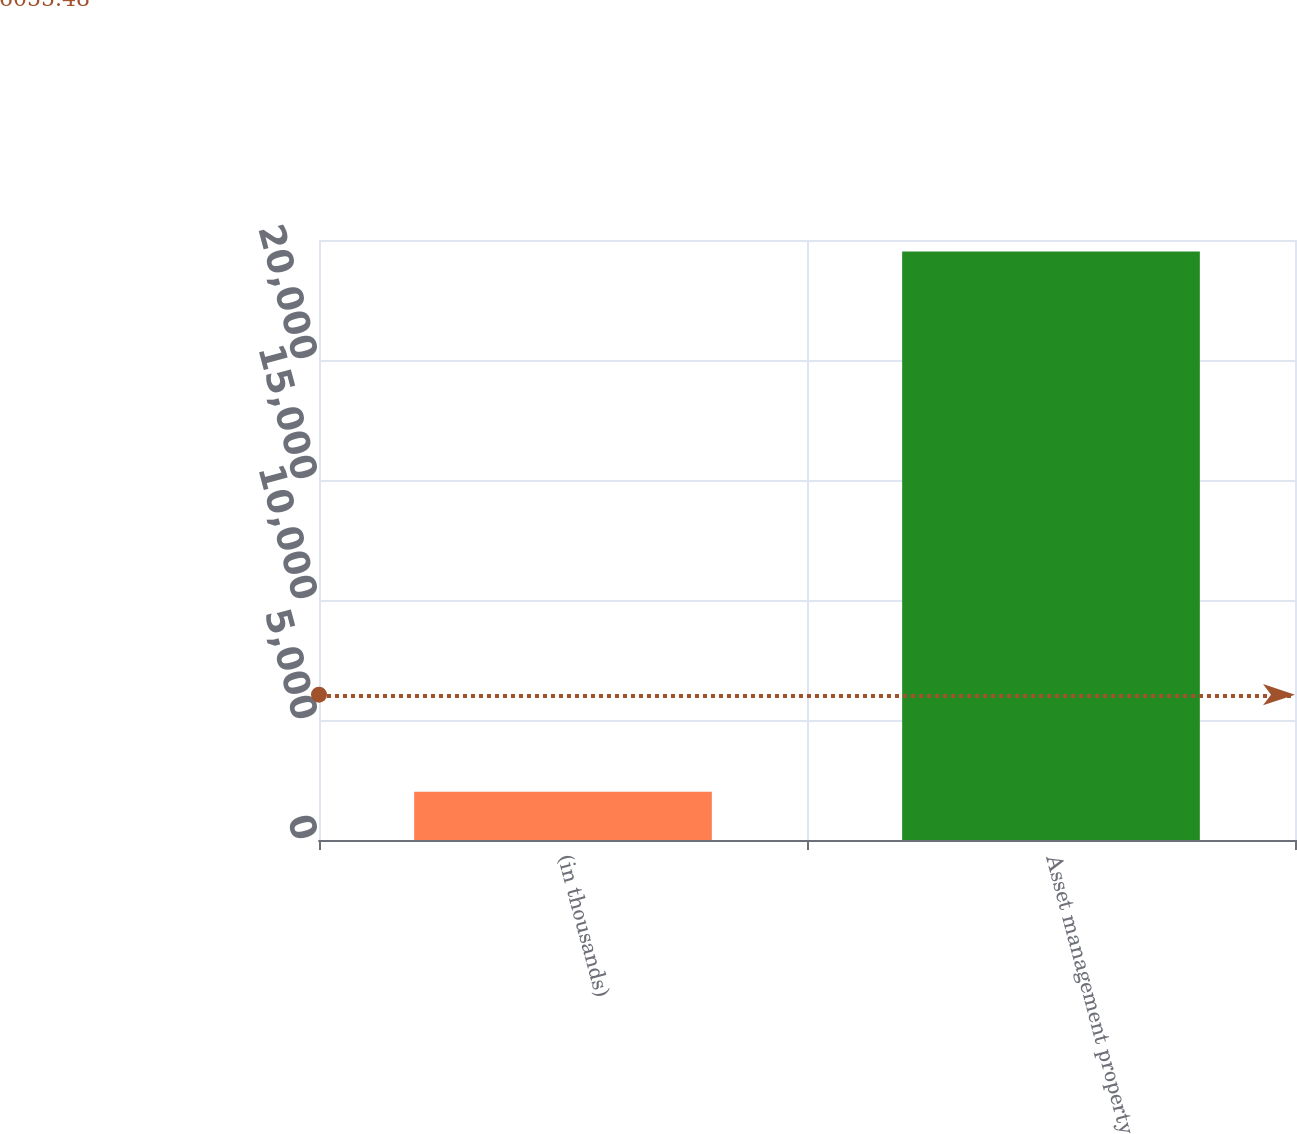Convert chart. <chart><loc_0><loc_0><loc_500><loc_500><bar_chart><fcel>(in thousands)<fcel>Asset management property<nl><fcel>2015<fcel>24519<nl></chart> 